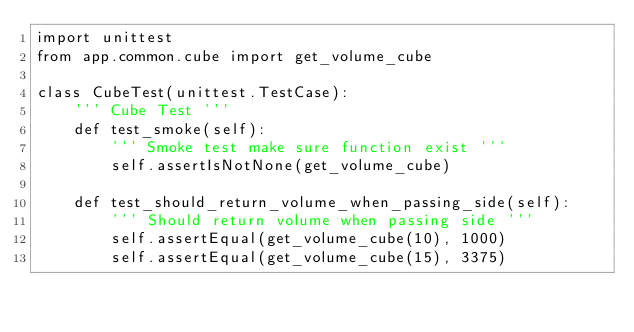<code> <loc_0><loc_0><loc_500><loc_500><_Python_>import unittest
from app.common.cube import get_volume_cube

class CubeTest(unittest.TestCase):
    ''' Cube Test '''
    def test_smoke(self):
        ''' Smoke test make sure function exist '''
        self.assertIsNotNone(get_volume_cube)

    def test_should_return_volume_when_passing_side(self):
        ''' Should return volume when passing side '''
        self.assertEqual(get_volume_cube(10), 1000)
        self.assertEqual(get_volume_cube(15), 3375)</code> 